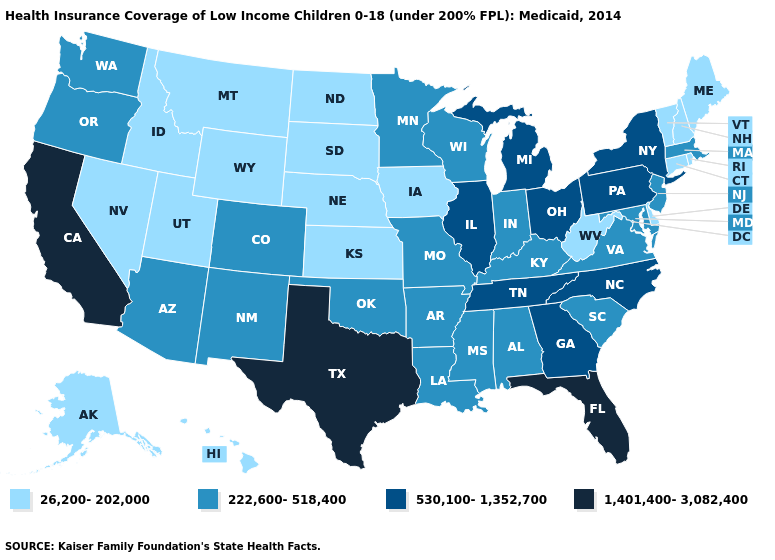What is the value of New Jersey?
Answer briefly. 222,600-518,400. Name the states that have a value in the range 530,100-1,352,700?
Short answer required. Georgia, Illinois, Michigan, New York, North Carolina, Ohio, Pennsylvania, Tennessee. Name the states that have a value in the range 530,100-1,352,700?
Give a very brief answer. Georgia, Illinois, Michigan, New York, North Carolina, Ohio, Pennsylvania, Tennessee. Name the states that have a value in the range 26,200-202,000?
Quick response, please. Alaska, Connecticut, Delaware, Hawaii, Idaho, Iowa, Kansas, Maine, Montana, Nebraska, Nevada, New Hampshire, North Dakota, Rhode Island, South Dakota, Utah, Vermont, West Virginia, Wyoming. Name the states that have a value in the range 26,200-202,000?
Write a very short answer. Alaska, Connecticut, Delaware, Hawaii, Idaho, Iowa, Kansas, Maine, Montana, Nebraska, Nevada, New Hampshire, North Dakota, Rhode Island, South Dakota, Utah, Vermont, West Virginia, Wyoming. Does Idaho have the highest value in the West?
Answer briefly. No. What is the lowest value in the MidWest?
Concise answer only. 26,200-202,000. Is the legend a continuous bar?
Answer briefly. No. Does New York have the same value as Ohio?
Answer briefly. Yes. What is the value of Alabama?
Keep it brief. 222,600-518,400. How many symbols are there in the legend?
Answer briefly. 4. Does South Dakota have the lowest value in the USA?
Concise answer only. Yes. What is the value of Mississippi?
Keep it brief. 222,600-518,400. What is the value of South Dakota?
Give a very brief answer. 26,200-202,000. Which states have the highest value in the USA?
Be succinct. California, Florida, Texas. 